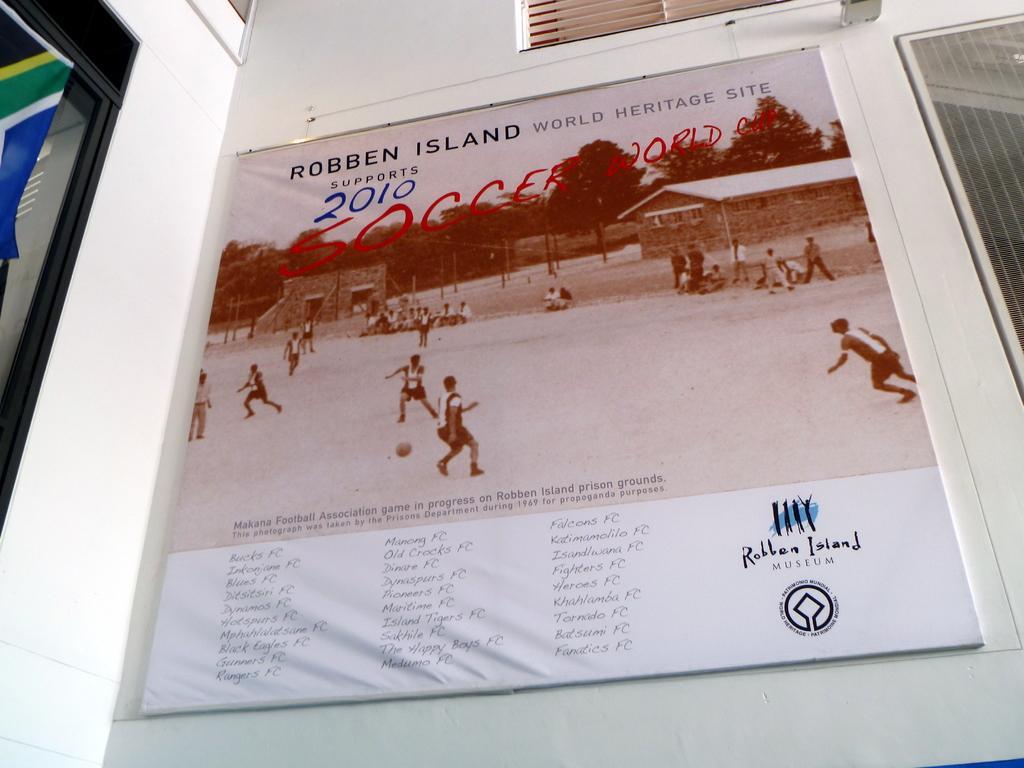Please provide a concise description of this image. In this picture I can see a board on the wall with some text and I can see picture of few people playing football and looks like flag on the left side. 